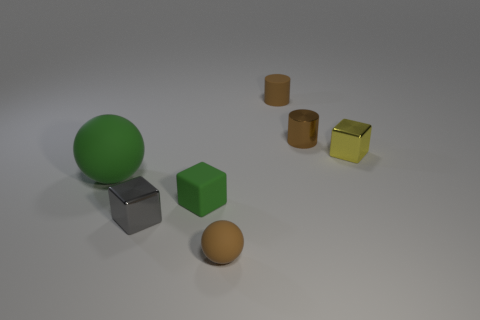Is the number of green matte cubes that are in front of the green matte cube greater than the number of tiny brown metallic cylinders?
Provide a succinct answer. No. The big matte ball is what color?
Your response must be concise. Green. What shape is the small metal object left of the tiny brown matte object in front of the tiny shiny cube to the right of the gray shiny cube?
Make the answer very short. Cube. What material is the tiny brown object that is to the left of the small brown metal thing and behind the big green rubber object?
Offer a terse response. Rubber. There is a matte thing that is behind the block that is to the right of the small green rubber block; what shape is it?
Make the answer very short. Cylinder. Are there any other things of the same color as the small ball?
Offer a terse response. Yes. Is the size of the brown shiny cylinder the same as the cylinder that is left of the shiny cylinder?
Offer a terse response. Yes. What number of tiny things are either purple metallic blocks or blocks?
Keep it short and to the point. 3. Is the number of green things greater than the number of gray balls?
Your response must be concise. Yes. There is a tiny rubber block that is left of the brown object in front of the yellow metal cube; what number of shiny blocks are right of it?
Make the answer very short. 1. 